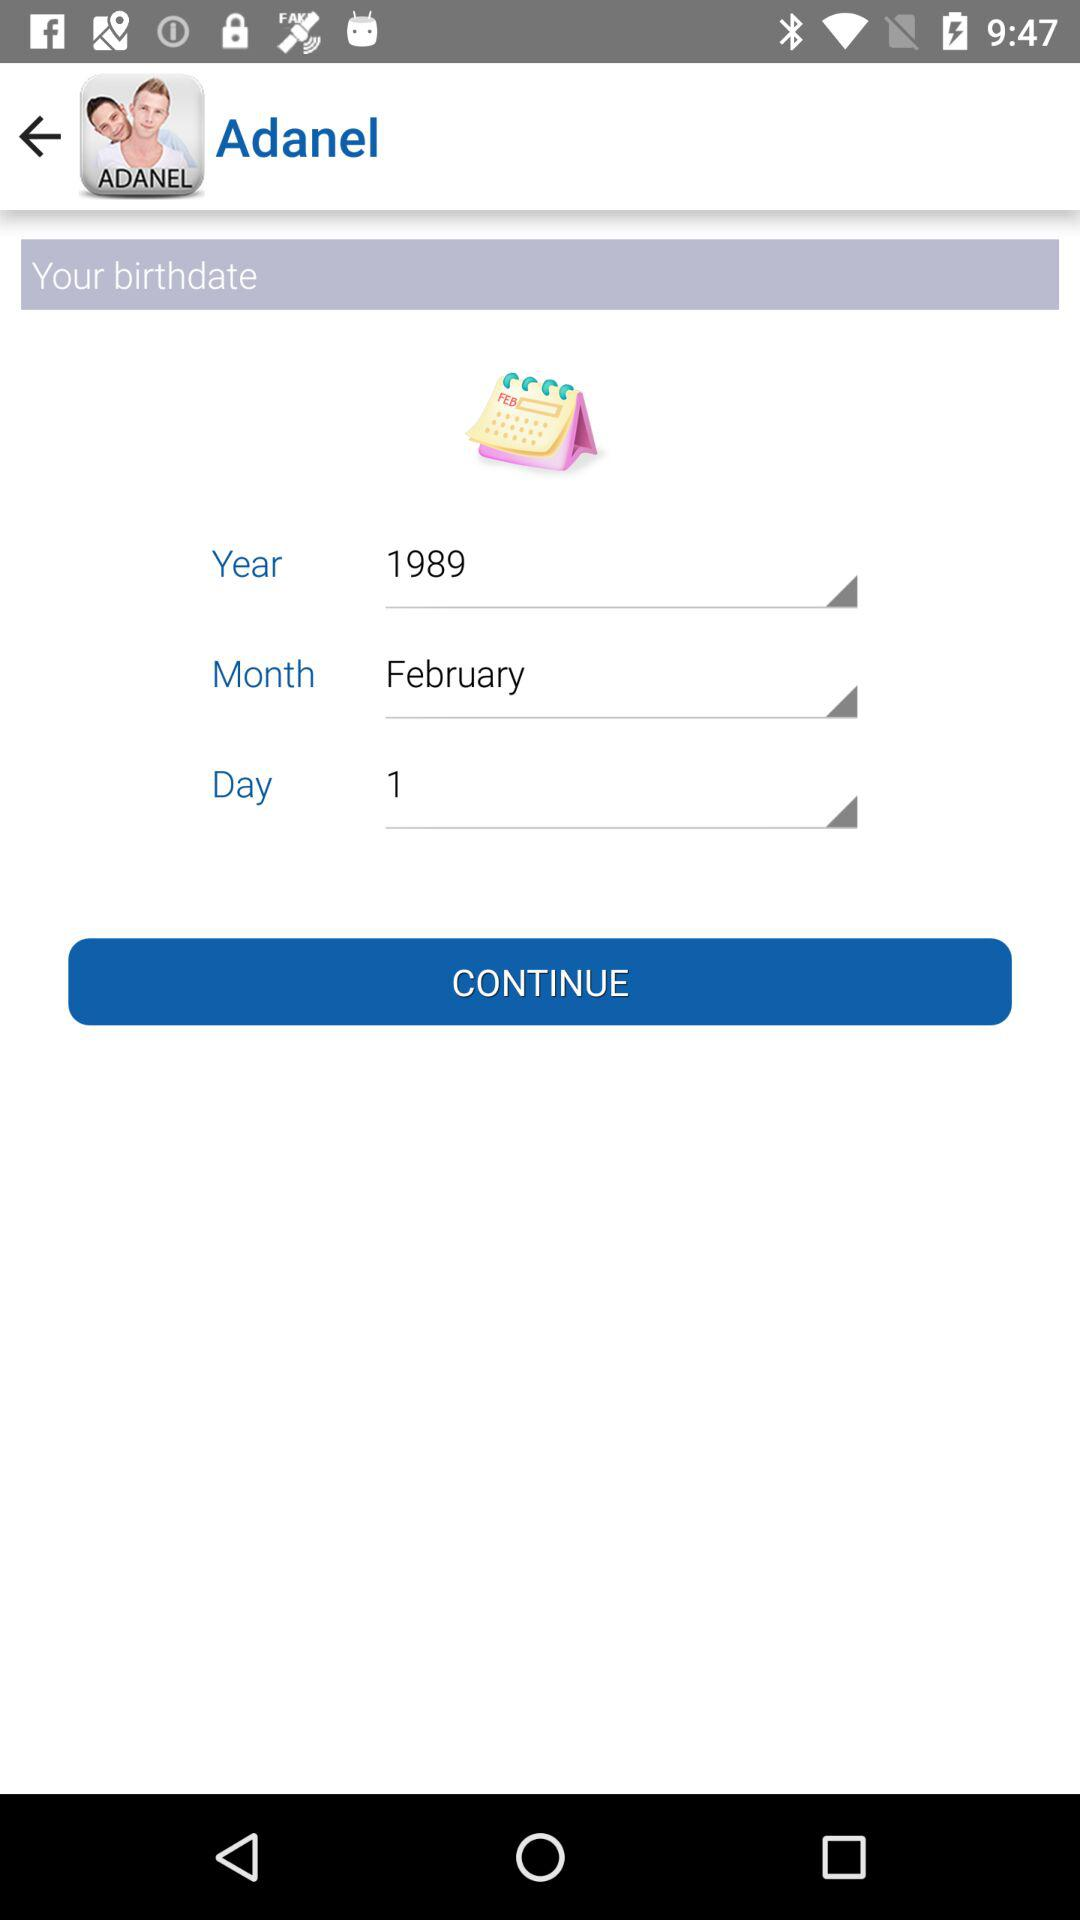What is the app name? The app name is "Adanel". 